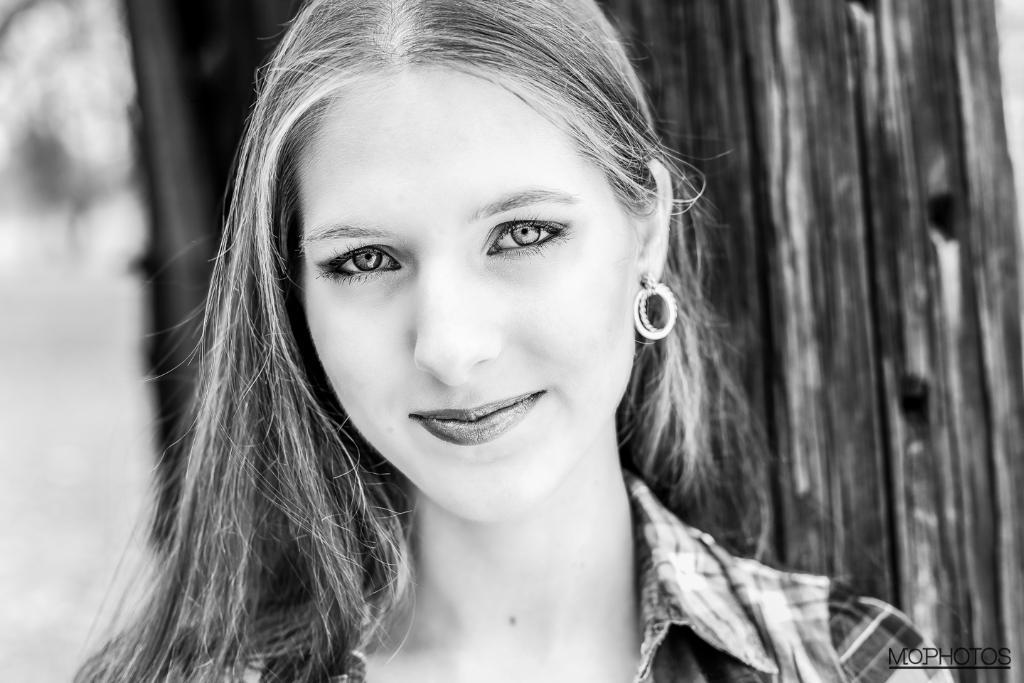Who is present in the image? There is a woman in the image. What expression does the woman have? The woman is smiling. How would you describe the background of the image? The background of the image is blurry. What color scheme is used in the image? The image is black and white. What type of cup is the woman holding in the image? There is no cup present in the image. Is the woman using a notebook in the image? There is no notebook present in the image. 